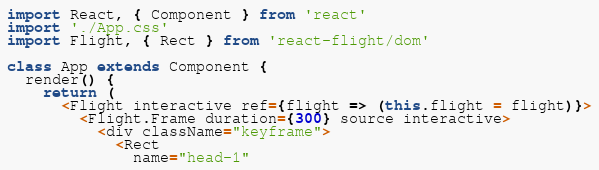Convert code to text. <code><loc_0><loc_0><loc_500><loc_500><_JavaScript_>import React, { Component } from 'react'
import './App.css'
import Flight, { Rect } from 'react-flight/dom'

class App extends Component {
  render() {
    return (
      <Flight interactive ref={flight => (this.flight = flight)}>
        <Flight.Frame duration={300} source interactive>
          <div className="keyframe">
            <Rect
              name="head-1"</code> 